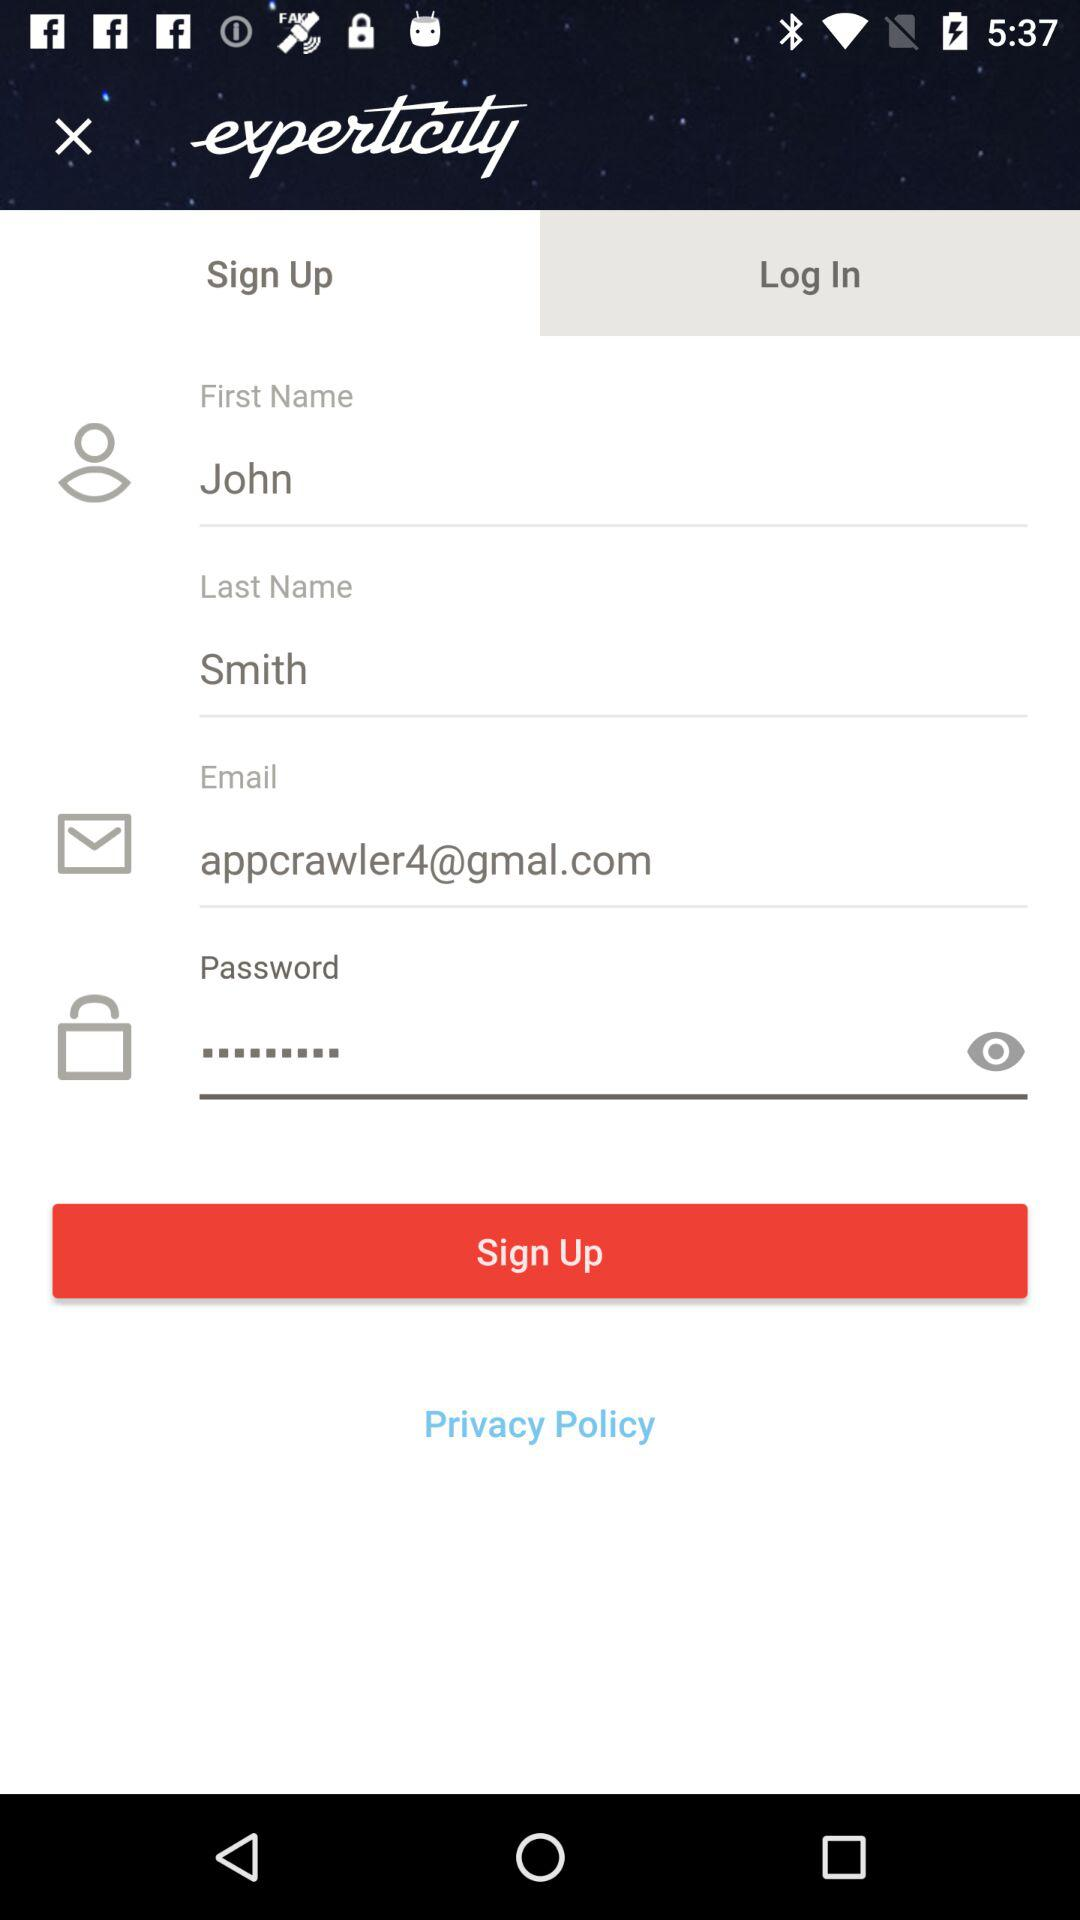What is the name of the application? The name of the application is "experticity". 